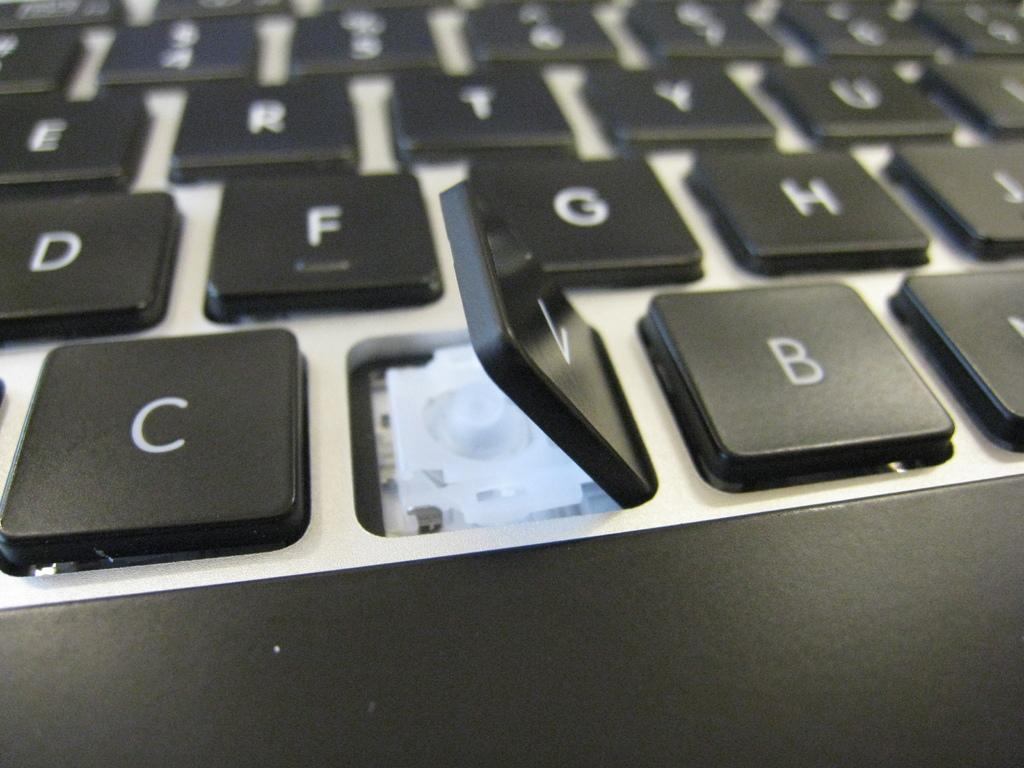<image>
Render a clear and concise summary of the photo. close-up of a keyboard with the V key loose from the board. 